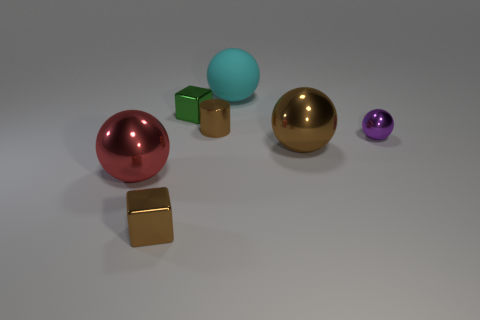Subtract all big brown spheres. How many spheres are left? 3 Add 1 cylinders. How many objects exist? 8 Subtract all brown balls. How many balls are left? 3 Subtract 0 yellow blocks. How many objects are left? 7 Subtract all spheres. How many objects are left? 3 Subtract all yellow blocks. Subtract all purple spheres. How many blocks are left? 2 Subtract all purple things. Subtract all large objects. How many objects are left? 3 Add 6 brown shiny spheres. How many brown shiny spheres are left? 7 Add 4 cyan objects. How many cyan objects exist? 5 